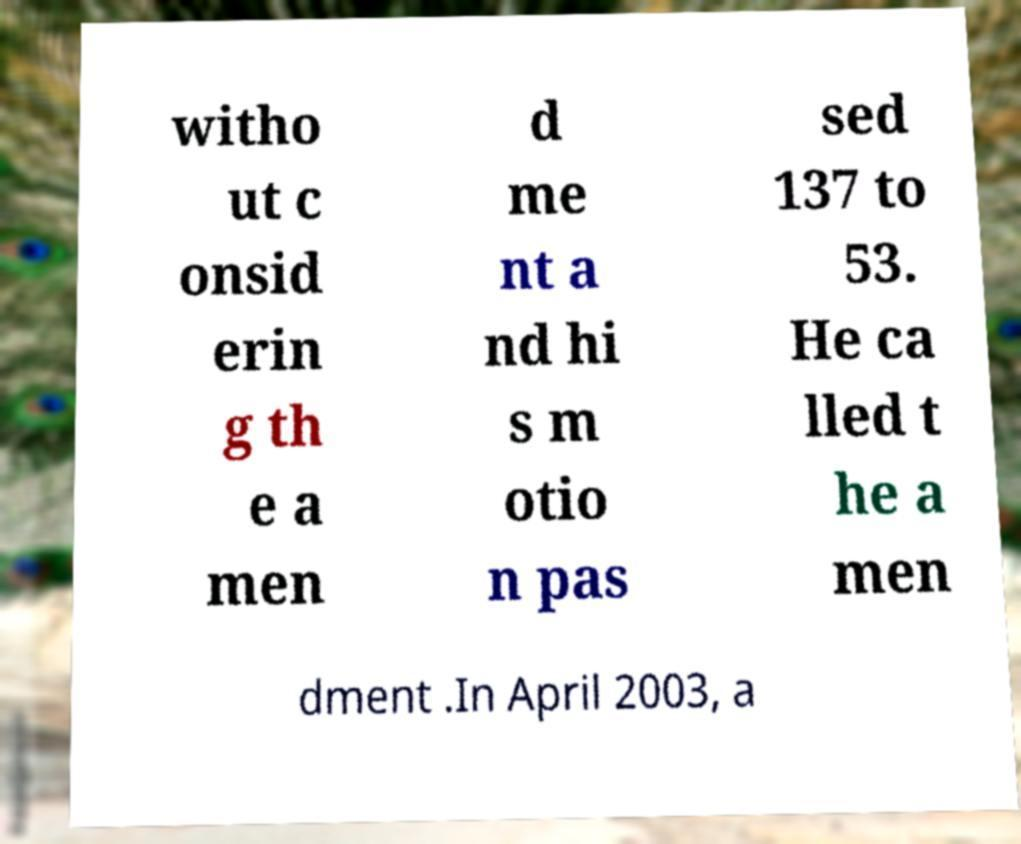Could you extract and type out the text from this image? witho ut c onsid erin g th e a men d me nt a nd hi s m otio n pas sed 137 to 53. He ca lled t he a men dment .In April 2003, a 